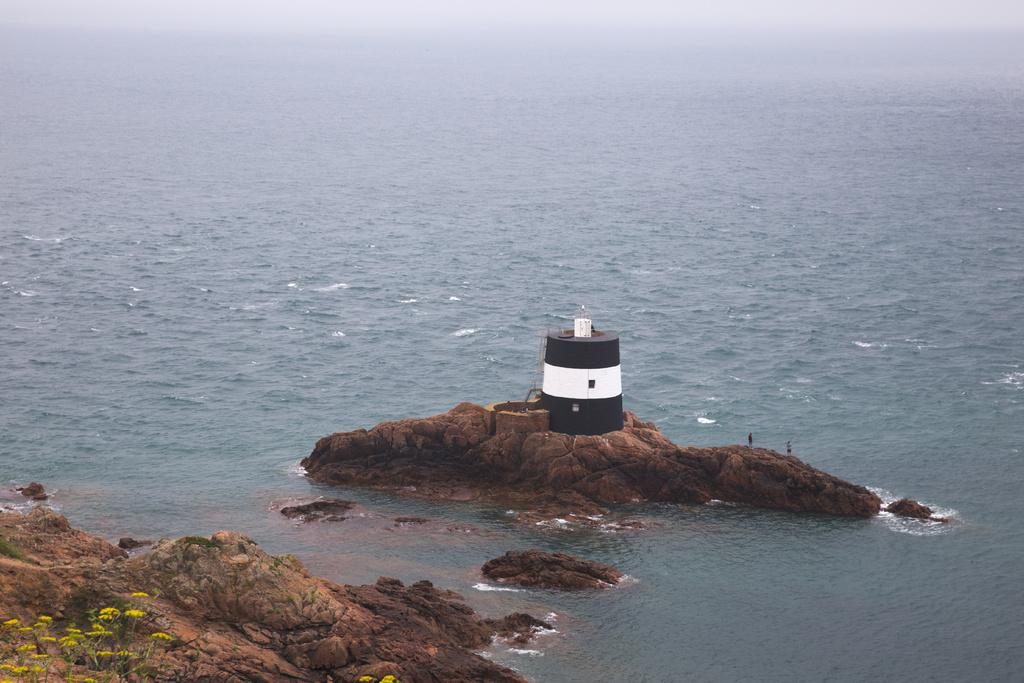What type of natural elements can be seen in the image? There are rocks, water, plants, and flowers in the image. What man-made structure is present in the image? There is a lighthouse in the image. How many people are in the image? There are two people in the image. What type of string can be seen holding up the flowers in the image? There is no string visible in the image; the flowers are not being held up by any visible support. 